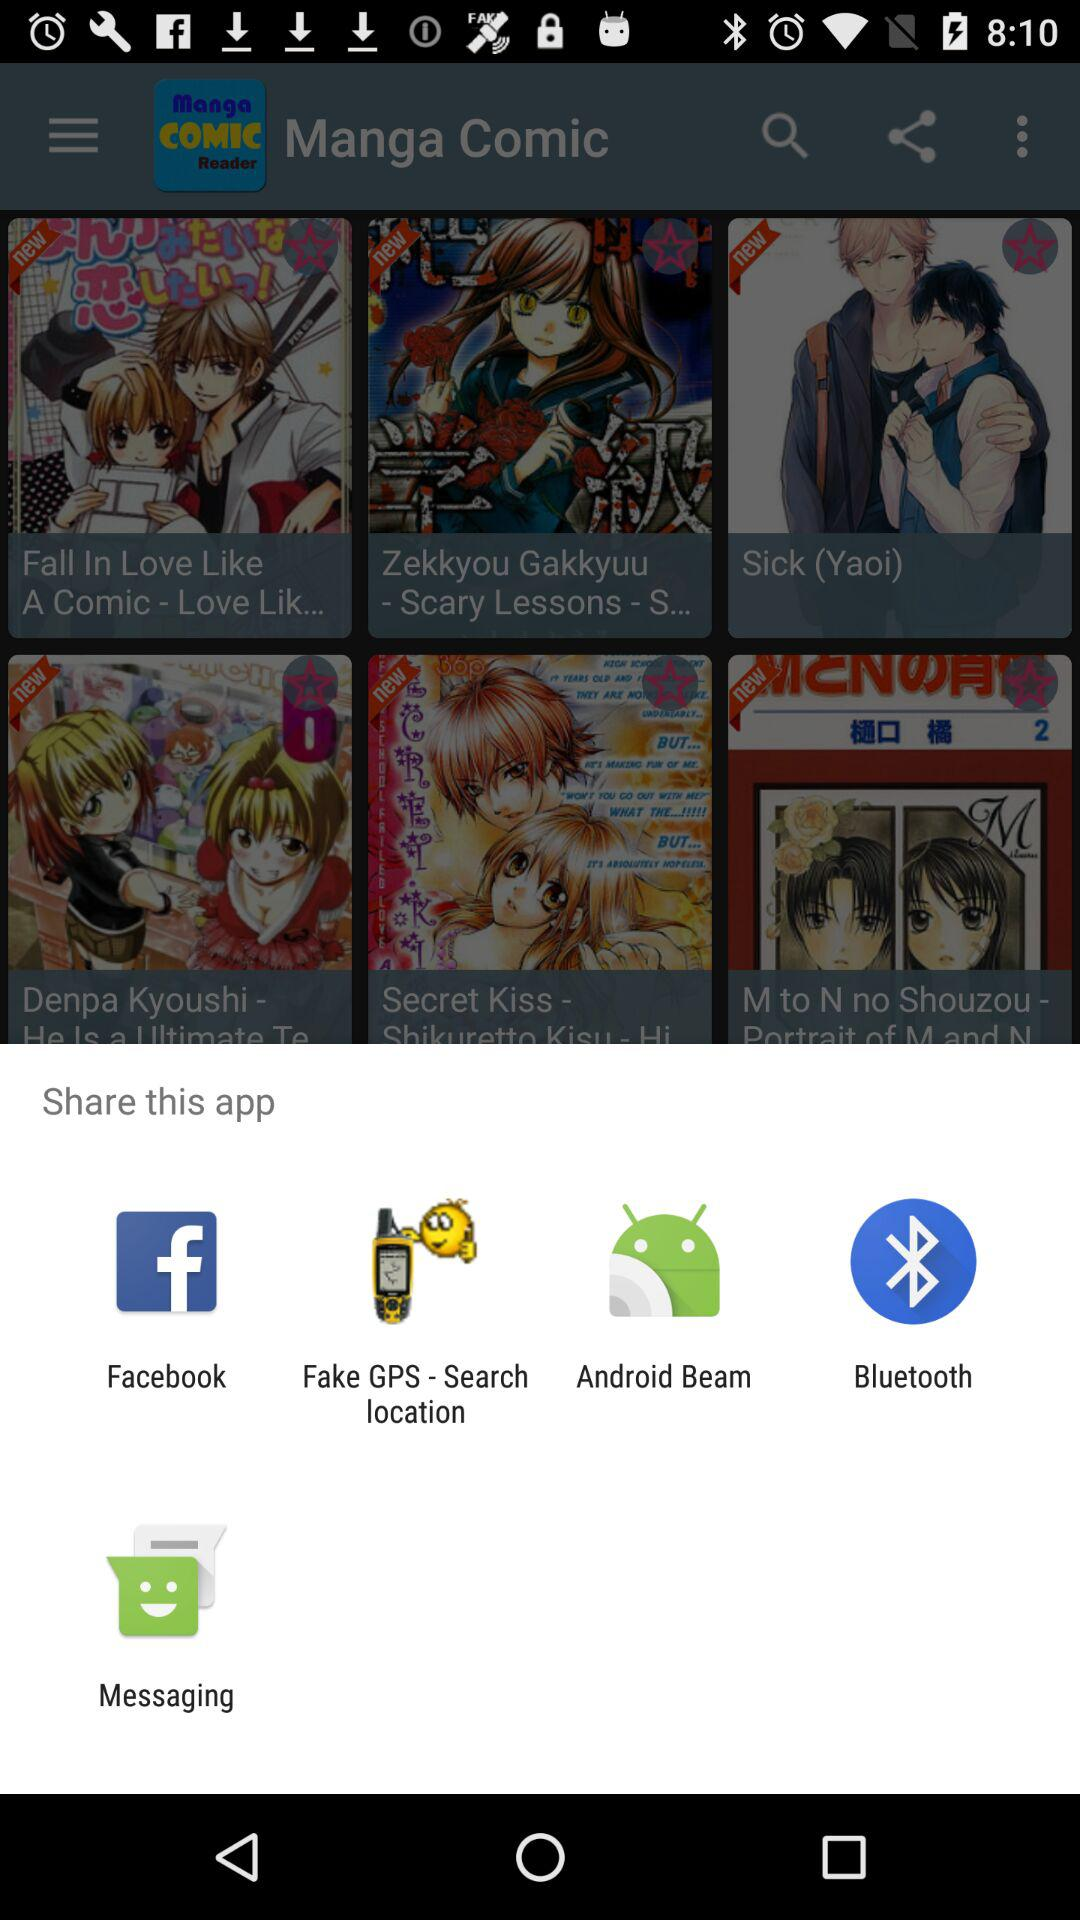Which comic is marked as a favorite?
When the provided information is insufficient, respond with <no answer>. <no answer> 